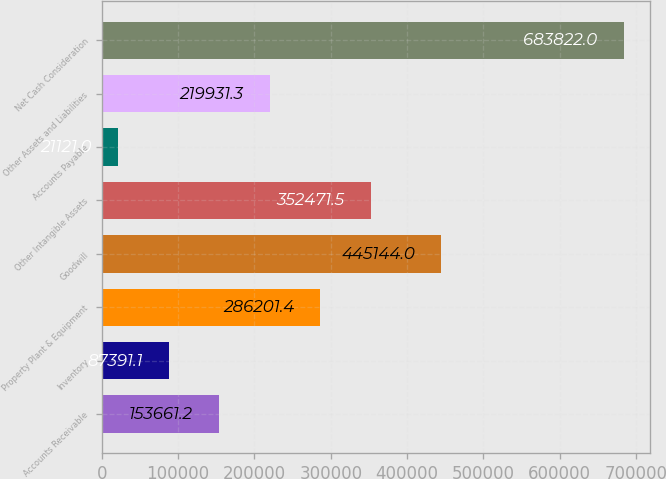Convert chart to OTSL. <chart><loc_0><loc_0><loc_500><loc_500><bar_chart><fcel>Accounts Receivable<fcel>Inventory<fcel>Property Plant & Equipment<fcel>Goodwill<fcel>Other Intangible Assets<fcel>Accounts Payable<fcel>Other Assets and Liabilities<fcel>Net Cash Consideration<nl><fcel>153661<fcel>87391.1<fcel>286201<fcel>445144<fcel>352472<fcel>21121<fcel>219931<fcel>683822<nl></chart> 